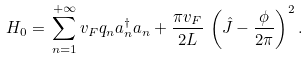<formula> <loc_0><loc_0><loc_500><loc_500>H _ { 0 } = \, \sum _ { n = 1 } ^ { + \infty } v _ { F } q _ { n } a _ { n } ^ { \dagger } a _ { n } + \frac { \pi v _ { F } } { 2 L } \, \left ( \hat { J } - \frac { \phi } { 2 \pi } \right ) ^ { 2 } .</formula> 